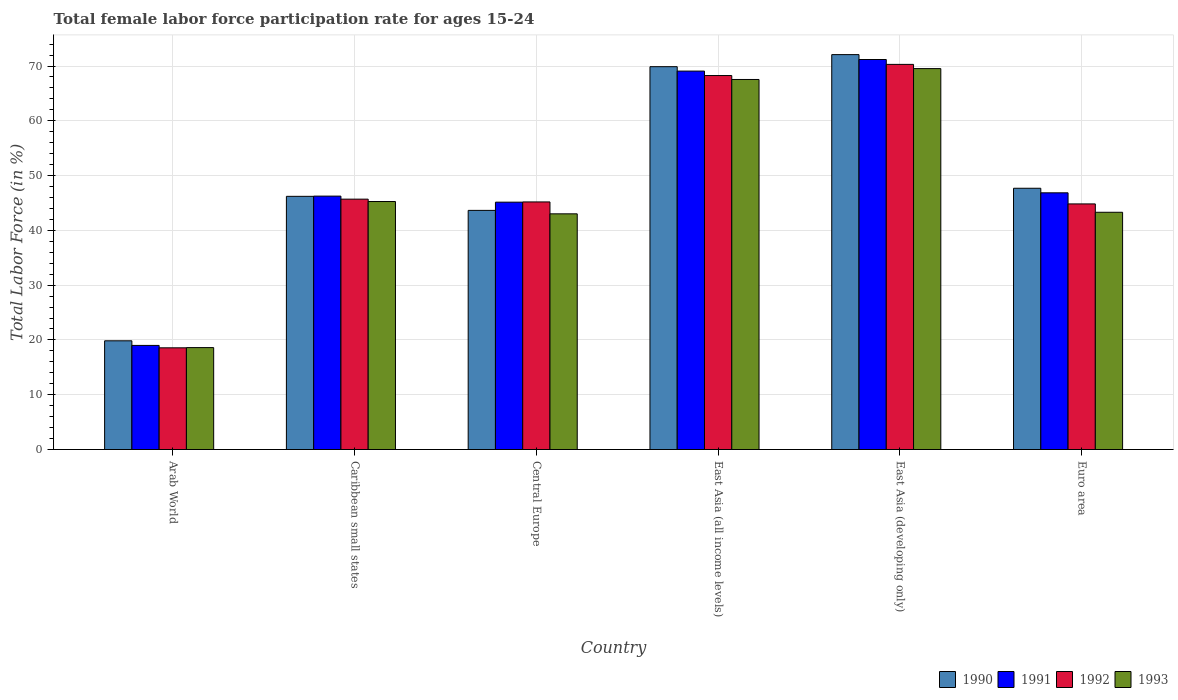Are the number of bars per tick equal to the number of legend labels?
Your answer should be compact. Yes. Are the number of bars on each tick of the X-axis equal?
Keep it short and to the point. Yes. How many bars are there on the 2nd tick from the left?
Keep it short and to the point. 4. What is the label of the 4th group of bars from the left?
Your answer should be very brief. East Asia (all income levels). What is the female labor force participation rate in 1992 in East Asia (developing only)?
Make the answer very short. 70.3. Across all countries, what is the maximum female labor force participation rate in 1990?
Give a very brief answer. 72.08. Across all countries, what is the minimum female labor force participation rate in 1990?
Make the answer very short. 19.84. In which country was the female labor force participation rate in 1990 maximum?
Your answer should be compact. East Asia (developing only). In which country was the female labor force participation rate in 1990 minimum?
Provide a succinct answer. Arab World. What is the total female labor force participation rate in 1993 in the graph?
Give a very brief answer. 287.27. What is the difference between the female labor force participation rate in 1990 in Central Europe and that in Euro area?
Your response must be concise. -4.04. What is the difference between the female labor force participation rate in 1993 in Euro area and the female labor force participation rate in 1991 in East Asia (developing only)?
Provide a short and direct response. -27.88. What is the average female labor force participation rate in 1991 per country?
Provide a succinct answer. 49.59. What is the difference between the female labor force participation rate of/in 1992 and female labor force participation rate of/in 1993 in East Asia (developing only)?
Provide a succinct answer. 0.77. In how many countries, is the female labor force participation rate in 1990 greater than 4 %?
Give a very brief answer. 6. What is the ratio of the female labor force participation rate in 1991 in Arab World to that in Central Europe?
Your response must be concise. 0.42. Is the difference between the female labor force participation rate in 1992 in Arab World and Caribbean small states greater than the difference between the female labor force participation rate in 1993 in Arab World and Caribbean small states?
Keep it short and to the point. No. What is the difference between the highest and the second highest female labor force participation rate in 1990?
Your answer should be very brief. 2.2. What is the difference between the highest and the lowest female labor force participation rate in 1990?
Provide a succinct answer. 52.24. Is the sum of the female labor force participation rate in 1990 in Arab World and Central Europe greater than the maximum female labor force participation rate in 1992 across all countries?
Your answer should be very brief. No. What does the 4th bar from the left in Euro area represents?
Keep it short and to the point. 1993. Is it the case that in every country, the sum of the female labor force participation rate in 1991 and female labor force participation rate in 1992 is greater than the female labor force participation rate in 1993?
Your response must be concise. Yes. How many bars are there?
Keep it short and to the point. 24. Are all the bars in the graph horizontal?
Make the answer very short. No. What is the difference between two consecutive major ticks on the Y-axis?
Offer a terse response. 10. Does the graph contain grids?
Give a very brief answer. Yes. What is the title of the graph?
Ensure brevity in your answer.  Total female labor force participation rate for ages 15-24. What is the label or title of the Y-axis?
Offer a terse response. Total Labor Force (in %). What is the Total Labor Force (in %) in 1990 in Arab World?
Your answer should be very brief. 19.84. What is the Total Labor Force (in %) in 1991 in Arab World?
Your response must be concise. 19. What is the Total Labor Force (in %) of 1992 in Arab World?
Make the answer very short. 18.56. What is the Total Labor Force (in %) in 1993 in Arab World?
Offer a terse response. 18.6. What is the Total Labor Force (in %) in 1990 in Caribbean small states?
Your answer should be compact. 46.21. What is the Total Labor Force (in %) in 1991 in Caribbean small states?
Offer a very short reply. 46.25. What is the Total Labor Force (in %) of 1992 in Caribbean small states?
Make the answer very short. 45.7. What is the Total Labor Force (in %) in 1993 in Caribbean small states?
Offer a terse response. 45.27. What is the Total Labor Force (in %) in 1990 in Central Europe?
Offer a very short reply. 43.65. What is the Total Labor Force (in %) in 1991 in Central Europe?
Provide a succinct answer. 45.15. What is the Total Labor Force (in %) in 1992 in Central Europe?
Offer a very short reply. 45.19. What is the Total Labor Force (in %) of 1993 in Central Europe?
Give a very brief answer. 43.02. What is the Total Labor Force (in %) in 1990 in East Asia (all income levels)?
Make the answer very short. 69.88. What is the Total Labor Force (in %) of 1991 in East Asia (all income levels)?
Give a very brief answer. 69.08. What is the Total Labor Force (in %) of 1992 in East Asia (all income levels)?
Provide a succinct answer. 68.26. What is the Total Labor Force (in %) of 1993 in East Asia (all income levels)?
Your answer should be very brief. 67.55. What is the Total Labor Force (in %) of 1990 in East Asia (developing only)?
Ensure brevity in your answer.  72.08. What is the Total Labor Force (in %) in 1991 in East Asia (developing only)?
Keep it short and to the point. 71.19. What is the Total Labor Force (in %) in 1992 in East Asia (developing only)?
Make the answer very short. 70.3. What is the Total Labor Force (in %) in 1993 in East Asia (developing only)?
Offer a terse response. 69.53. What is the Total Labor Force (in %) of 1990 in Euro area?
Keep it short and to the point. 47.69. What is the Total Labor Force (in %) in 1991 in Euro area?
Keep it short and to the point. 46.86. What is the Total Labor Force (in %) in 1992 in Euro area?
Provide a succinct answer. 44.83. What is the Total Labor Force (in %) in 1993 in Euro area?
Your response must be concise. 43.31. Across all countries, what is the maximum Total Labor Force (in %) in 1990?
Your response must be concise. 72.08. Across all countries, what is the maximum Total Labor Force (in %) in 1991?
Your answer should be very brief. 71.19. Across all countries, what is the maximum Total Labor Force (in %) of 1992?
Your answer should be compact. 70.3. Across all countries, what is the maximum Total Labor Force (in %) in 1993?
Ensure brevity in your answer.  69.53. Across all countries, what is the minimum Total Labor Force (in %) of 1990?
Ensure brevity in your answer.  19.84. Across all countries, what is the minimum Total Labor Force (in %) of 1991?
Make the answer very short. 19. Across all countries, what is the minimum Total Labor Force (in %) in 1992?
Keep it short and to the point. 18.56. Across all countries, what is the minimum Total Labor Force (in %) in 1993?
Ensure brevity in your answer.  18.6. What is the total Total Labor Force (in %) of 1990 in the graph?
Your response must be concise. 299.36. What is the total Total Labor Force (in %) of 1991 in the graph?
Keep it short and to the point. 297.53. What is the total Total Labor Force (in %) in 1992 in the graph?
Your response must be concise. 292.86. What is the total Total Labor Force (in %) of 1993 in the graph?
Your response must be concise. 287.27. What is the difference between the Total Labor Force (in %) of 1990 in Arab World and that in Caribbean small states?
Make the answer very short. -26.37. What is the difference between the Total Labor Force (in %) of 1991 in Arab World and that in Caribbean small states?
Keep it short and to the point. -27.25. What is the difference between the Total Labor Force (in %) of 1992 in Arab World and that in Caribbean small states?
Give a very brief answer. -27.14. What is the difference between the Total Labor Force (in %) of 1993 in Arab World and that in Caribbean small states?
Make the answer very short. -26.66. What is the difference between the Total Labor Force (in %) of 1990 in Arab World and that in Central Europe?
Keep it short and to the point. -23.81. What is the difference between the Total Labor Force (in %) in 1991 in Arab World and that in Central Europe?
Your answer should be very brief. -26.15. What is the difference between the Total Labor Force (in %) in 1992 in Arab World and that in Central Europe?
Provide a succinct answer. -26.63. What is the difference between the Total Labor Force (in %) in 1993 in Arab World and that in Central Europe?
Provide a short and direct response. -24.42. What is the difference between the Total Labor Force (in %) in 1990 in Arab World and that in East Asia (all income levels)?
Your answer should be very brief. -50.04. What is the difference between the Total Labor Force (in %) in 1991 in Arab World and that in East Asia (all income levels)?
Provide a short and direct response. -50.07. What is the difference between the Total Labor Force (in %) of 1992 in Arab World and that in East Asia (all income levels)?
Give a very brief answer. -49.7. What is the difference between the Total Labor Force (in %) in 1993 in Arab World and that in East Asia (all income levels)?
Your answer should be very brief. -48.94. What is the difference between the Total Labor Force (in %) in 1990 in Arab World and that in East Asia (developing only)?
Give a very brief answer. -52.24. What is the difference between the Total Labor Force (in %) of 1991 in Arab World and that in East Asia (developing only)?
Your answer should be compact. -52.19. What is the difference between the Total Labor Force (in %) in 1992 in Arab World and that in East Asia (developing only)?
Ensure brevity in your answer.  -51.74. What is the difference between the Total Labor Force (in %) of 1993 in Arab World and that in East Asia (developing only)?
Your answer should be compact. -50.93. What is the difference between the Total Labor Force (in %) in 1990 in Arab World and that in Euro area?
Your answer should be very brief. -27.85. What is the difference between the Total Labor Force (in %) in 1991 in Arab World and that in Euro area?
Offer a terse response. -27.85. What is the difference between the Total Labor Force (in %) in 1992 in Arab World and that in Euro area?
Your answer should be very brief. -26.27. What is the difference between the Total Labor Force (in %) of 1993 in Arab World and that in Euro area?
Provide a short and direct response. -24.7. What is the difference between the Total Labor Force (in %) of 1990 in Caribbean small states and that in Central Europe?
Ensure brevity in your answer.  2.56. What is the difference between the Total Labor Force (in %) in 1991 in Caribbean small states and that in Central Europe?
Your response must be concise. 1.1. What is the difference between the Total Labor Force (in %) in 1992 in Caribbean small states and that in Central Europe?
Provide a succinct answer. 0.51. What is the difference between the Total Labor Force (in %) in 1993 in Caribbean small states and that in Central Europe?
Ensure brevity in your answer.  2.25. What is the difference between the Total Labor Force (in %) in 1990 in Caribbean small states and that in East Asia (all income levels)?
Your answer should be compact. -23.67. What is the difference between the Total Labor Force (in %) in 1991 in Caribbean small states and that in East Asia (all income levels)?
Keep it short and to the point. -22.82. What is the difference between the Total Labor Force (in %) of 1992 in Caribbean small states and that in East Asia (all income levels)?
Keep it short and to the point. -22.56. What is the difference between the Total Labor Force (in %) of 1993 in Caribbean small states and that in East Asia (all income levels)?
Your answer should be very brief. -22.28. What is the difference between the Total Labor Force (in %) in 1990 in Caribbean small states and that in East Asia (developing only)?
Offer a very short reply. -25.87. What is the difference between the Total Labor Force (in %) of 1991 in Caribbean small states and that in East Asia (developing only)?
Make the answer very short. -24.94. What is the difference between the Total Labor Force (in %) of 1992 in Caribbean small states and that in East Asia (developing only)?
Keep it short and to the point. -24.6. What is the difference between the Total Labor Force (in %) of 1993 in Caribbean small states and that in East Asia (developing only)?
Offer a very short reply. -24.26. What is the difference between the Total Labor Force (in %) in 1990 in Caribbean small states and that in Euro area?
Provide a short and direct response. -1.48. What is the difference between the Total Labor Force (in %) of 1991 in Caribbean small states and that in Euro area?
Offer a terse response. -0.6. What is the difference between the Total Labor Force (in %) in 1992 in Caribbean small states and that in Euro area?
Your answer should be compact. 0.87. What is the difference between the Total Labor Force (in %) in 1993 in Caribbean small states and that in Euro area?
Your answer should be compact. 1.96. What is the difference between the Total Labor Force (in %) in 1990 in Central Europe and that in East Asia (all income levels)?
Provide a short and direct response. -26.23. What is the difference between the Total Labor Force (in %) of 1991 in Central Europe and that in East Asia (all income levels)?
Provide a succinct answer. -23.93. What is the difference between the Total Labor Force (in %) of 1992 in Central Europe and that in East Asia (all income levels)?
Provide a short and direct response. -23.07. What is the difference between the Total Labor Force (in %) of 1993 in Central Europe and that in East Asia (all income levels)?
Give a very brief answer. -24.53. What is the difference between the Total Labor Force (in %) of 1990 in Central Europe and that in East Asia (developing only)?
Your answer should be compact. -28.43. What is the difference between the Total Labor Force (in %) in 1991 in Central Europe and that in East Asia (developing only)?
Make the answer very short. -26.04. What is the difference between the Total Labor Force (in %) in 1992 in Central Europe and that in East Asia (developing only)?
Ensure brevity in your answer.  -25.11. What is the difference between the Total Labor Force (in %) of 1993 in Central Europe and that in East Asia (developing only)?
Offer a very short reply. -26.51. What is the difference between the Total Labor Force (in %) in 1990 in Central Europe and that in Euro area?
Offer a very short reply. -4.04. What is the difference between the Total Labor Force (in %) of 1991 in Central Europe and that in Euro area?
Keep it short and to the point. -1.7. What is the difference between the Total Labor Force (in %) in 1992 in Central Europe and that in Euro area?
Your response must be concise. 0.36. What is the difference between the Total Labor Force (in %) in 1993 in Central Europe and that in Euro area?
Your answer should be very brief. -0.29. What is the difference between the Total Labor Force (in %) in 1991 in East Asia (all income levels) and that in East Asia (developing only)?
Your answer should be compact. -2.11. What is the difference between the Total Labor Force (in %) in 1992 in East Asia (all income levels) and that in East Asia (developing only)?
Your answer should be very brief. -2.04. What is the difference between the Total Labor Force (in %) of 1993 in East Asia (all income levels) and that in East Asia (developing only)?
Make the answer very short. -1.98. What is the difference between the Total Labor Force (in %) of 1990 in East Asia (all income levels) and that in Euro area?
Ensure brevity in your answer.  22.19. What is the difference between the Total Labor Force (in %) of 1991 in East Asia (all income levels) and that in Euro area?
Your answer should be very brief. 22.22. What is the difference between the Total Labor Force (in %) of 1992 in East Asia (all income levels) and that in Euro area?
Give a very brief answer. 23.43. What is the difference between the Total Labor Force (in %) of 1993 in East Asia (all income levels) and that in Euro area?
Provide a succinct answer. 24.24. What is the difference between the Total Labor Force (in %) of 1990 in East Asia (developing only) and that in Euro area?
Your answer should be very brief. 24.39. What is the difference between the Total Labor Force (in %) of 1991 in East Asia (developing only) and that in Euro area?
Offer a very short reply. 24.34. What is the difference between the Total Labor Force (in %) of 1992 in East Asia (developing only) and that in Euro area?
Provide a short and direct response. 25.47. What is the difference between the Total Labor Force (in %) in 1993 in East Asia (developing only) and that in Euro area?
Give a very brief answer. 26.22. What is the difference between the Total Labor Force (in %) of 1990 in Arab World and the Total Labor Force (in %) of 1991 in Caribbean small states?
Make the answer very short. -26.41. What is the difference between the Total Labor Force (in %) of 1990 in Arab World and the Total Labor Force (in %) of 1992 in Caribbean small states?
Your answer should be compact. -25.86. What is the difference between the Total Labor Force (in %) of 1990 in Arab World and the Total Labor Force (in %) of 1993 in Caribbean small states?
Provide a succinct answer. -25.42. What is the difference between the Total Labor Force (in %) of 1991 in Arab World and the Total Labor Force (in %) of 1992 in Caribbean small states?
Ensure brevity in your answer.  -26.7. What is the difference between the Total Labor Force (in %) in 1991 in Arab World and the Total Labor Force (in %) in 1993 in Caribbean small states?
Your response must be concise. -26.27. What is the difference between the Total Labor Force (in %) of 1992 in Arab World and the Total Labor Force (in %) of 1993 in Caribbean small states?
Give a very brief answer. -26.7. What is the difference between the Total Labor Force (in %) in 1990 in Arab World and the Total Labor Force (in %) in 1991 in Central Europe?
Offer a terse response. -25.31. What is the difference between the Total Labor Force (in %) in 1990 in Arab World and the Total Labor Force (in %) in 1992 in Central Europe?
Ensure brevity in your answer.  -25.35. What is the difference between the Total Labor Force (in %) in 1990 in Arab World and the Total Labor Force (in %) in 1993 in Central Europe?
Make the answer very short. -23.17. What is the difference between the Total Labor Force (in %) of 1991 in Arab World and the Total Labor Force (in %) of 1992 in Central Europe?
Your answer should be compact. -26.19. What is the difference between the Total Labor Force (in %) of 1991 in Arab World and the Total Labor Force (in %) of 1993 in Central Europe?
Make the answer very short. -24.02. What is the difference between the Total Labor Force (in %) in 1992 in Arab World and the Total Labor Force (in %) in 1993 in Central Europe?
Ensure brevity in your answer.  -24.46. What is the difference between the Total Labor Force (in %) in 1990 in Arab World and the Total Labor Force (in %) in 1991 in East Asia (all income levels)?
Offer a terse response. -49.23. What is the difference between the Total Labor Force (in %) of 1990 in Arab World and the Total Labor Force (in %) of 1992 in East Asia (all income levels)?
Offer a terse response. -48.42. What is the difference between the Total Labor Force (in %) of 1990 in Arab World and the Total Labor Force (in %) of 1993 in East Asia (all income levels)?
Provide a succinct answer. -47.7. What is the difference between the Total Labor Force (in %) in 1991 in Arab World and the Total Labor Force (in %) in 1992 in East Asia (all income levels)?
Offer a very short reply. -49.26. What is the difference between the Total Labor Force (in %) of 1991 in Arab World and the Total Labor Force (in %) of 1993 in East Asia (all income levels)?
Make the answer very short. -48.54. What is the difference between the Total Labor Force (in %) of 1992 in Arab World and the Total Labor Force (in %) of 1993 in East Asia (all income levels)?
Your answer should be compact. -48.98. What is the difference between the Total Labor Force (in %) in 1990 in Arab World and the Total Labor Force (in %) in 1991 in East Asia (developing only)?
Offer a very short reply. -51.35. What is the difference between the Total Labor Force (in %) of 1990 in Arab World and the Total Labor Force (in %) of 1992 in East Asia (developing only)?
Keep it short and to the point. -50.46. What is the difference between the Total Labor Force (in %) of 1990 in Arab World and the Total Labor Force (in %) of 1993 in East Asia (developing only)?
Ensure brevity in your answer.  -49.68. What is the difference between the Total Labor Force (in %) of 1991 in Arab World and the Total Labor Force (in %) of 1992 in East Asia (developing only)?
Your response must be concise. -51.3. What is the difference between the Total Labor Force (in %) of 1991 in Arab World and the Total Labor Force (in %) of 1993 in East Asia (developing only)?
Offer a terse response. -50.53. What is the difference between the Total Labor Force (in %) in 1992 in Arab World and the Total Labor Force (in %) in 1993 in East Asia (developing only)?
Ensure brevity in your answer.  -50.97. What is the difference between the Total Labor Force (in %) of 1990 in Arab World and the Total Labor Force (in %) of 1991 in Euro area?
Offer a terse response. -27.01. What is the difference between the Total Labor Force (in %) of 1990 in Arab World and the Total Labor Force (in %) of 1992 in Euro area?
Give a very brief answer. -24.99. What is the difference between the Total Labor Force (in %) of 1990 in Arab World and the Total Labor Force (in %) of 1993 in Euro area?
Keep it short and to the point. -23.46. What is the difference between the Total Labor Force (in %) in 1991 in Arab World and the Total Labor Force (in %) in 1992 in Euro area?
Offer a very short reply. -25.83. What is the difference between the Total Labor Force (in %) of 1991 in Arab World and the Total Labor Force (in %) of 1993 in Euro area?
Offer a very short reply. -24.3. What is the difference between the Total Labor Force (in %) of 1992 in Arab World and the Total Labor Force (in %) of 1993 in Euro area?
Provide a succinct answer. -24.74. What is the difference between the Total Labor Force (in %) in 1990 in Caribbean small states and the Total Labor Force (in %) in 1991 in Central Europe?
Provide a succinct answer. 1.06. What is the difference between the Total Labor Force (in %) of 1990 in Caribbean small states and the Total Labor Force (in %) of 1992 in Central Europe?
Offer a very short reply. 1.02. What is the difference between the Total Labor Force (in %) in 1990 in Caribbean small states and the Total Labor Force (in %) in 1993 in Central Europe?
Provide a succinct answer. 3.19. What is the difference between the Total Labor Force (in %) in 1991 in Caribbean small states and the Total Labor Force (in %) in 1992 in Central Europe?
Provide a short and direct response. 1.06. What is the difference between the Total Labor Force (in %) of 1991 in Caribbean small states and the Total Labor Force (in %) of 1993 in Central Europe?
Keep it short and to the point. 3.23. What is the difference between the Total Labor Force (in %) in 1992 in Caribbean small states and the Total Labor Force (in %) in 1993 in Central Europe?
Your answer should be very brief. 2.68. What is the difference between the Total Labor Force (in %) of 1990 in Caribbean small states and the Total Labor Force (in %) of 1991 in East Asia (all income levels)?
Your answer should be compact. -22.86. What is the difference between the Total Labor Force (in %) in 1990 in Caribbean small states and the Total Labor Force (in %) in 1992 in East Asia (all income levels)?
Ensure brevity in your answer.  -22.05. What is the difference between the Total Labor Force (in %) in 1990 in Caribbean small states and the Total Labor Force (in %) in 1993 in East Asia (all income levels)?
Give a very brief answer. -21.33. What is the difference between the Total Labor Force (in %) of 1991 in Caribbean small states and the Total Labor Force (in %) of 1992 in East Asia (all income levels)?
Provide a succinct answer. -22.01. What is the difference between the Total Labor Force (in %) in 1991 in Caribbean small states and the Total Labor Force (in %) in 1993 in East Asia (all income levels)?
Your answer should be compact. -21.29. What is the difference between the Total Labor Force (in %) of 1992 in Caribbean small states and the Total Labor Force (in %) of 1993 in East Asia (all income levels)?
Your response must be concise. -21.84. What is the difference between the Total Labor Force (in %) of 1990 in Caribbean small states and the Total Labor Force (in %) of 1991 in East Asia (developing only)?
Keep it short and to the point. -24.98. What is the difference between the Total Labor Force (in %) in 1990 in Caribbean small states and the Total Labor Force (in %) in 1992 in East Asia (developing only)?
Offer a very short reply. -24.09. What is the difference between the Total Labor Force (in %) of 1990 in Caribbean small states and the Total Labor Force (in %) of 1993 in East Asia (developing only)?
Make the answer very short. -23.32. What is the difference between the Total Labor Force (in %) of 1991 in Caribbean small states and the Total Labor Force (in %) of 1992 in East Asia (developing only)?
Your response must be concise. -24.05. What is the difference between the Total Labor Force (in %) in 1991 in Caribbean small states and the Total Labor Force (in %) in 1993 in East Asia (developing only)?
Provide a succinct answer. -23.28. What is the difference between the Total Labor Force (in %) in 1992 in Caribbean small states and the Total Labor Force (in %) in 1993 in East Asia (developing only)?
Make the answer very short. -23.83. What is the difference between the Total Labor Force (in %) of 1990 in Caribbean small states and the Total Labor Force (in %) of 1991 in Euro area?
Provide a short and direct response. -0.64. What is the difference between the Total Labor Force (in %) in 1990 in Caribbean small states and the Total Labor Force (in %) in 1992 in Euro area?
Keep it short and to the point. 1.38. What is the difference between the Total Labor Force (in %) of 1990 in Caribbean small states and the Total Labor Force (in %) of 1993 in Euro area?
Give a very brief answer. 2.91. What is the difference between the Total Labor Force (in %) in 1991 in Caribbean small states and the Total Labor Force (in %) in 1992 in Euro area?
Provide a short and direct response. 1.42. What is the difference between the Total Labor Force (in %) in 1991 in Caribbean small states and the Total Labor Force (in %) in 1993 in Euro area?
Provide a short and direct response. 2.95. What is the difference between the Total Labor Force (in %) in 1992 in Caribbean small states and the Total Labor Force (in %) in 1993 in Euro area?
Provide a succinct answer. 2.4. What is the difference between the Total Labor Force (in %) of 1990 in Central Europe and the Total Labor Force (in %) of 1991 in East Asia (all income levels)?
Your answer should be compact. -25.43. What is the difference between the Total Labor Force (in %) of 1990 in Central Europe and the Total Labor Force (in %) of 1992 in East Asia (all income levels)?
Your response must be concise. -24.61. What is the difference between the Total Labor Force (in %) in 1990 in Central Europe and the Total Labor Force (in %) in 1993 in East Asia (all income levels)?
Keep it short and to the point. -23.89. What is the difference between the Total Labor Force (in %) in 1991 in Central Europe and the Total Labor Force (in %) in 1992 in East Asia (all income levels)?
Offer a very short reply. -23.11. What is the difference between the Total Labor Force (in %) of 1991 in Central Europe and the Total Labor Force (in %) of 1993 in East Asia (all income levels)?
Your answer should be compact. -22.39. What is the difference between the Total Labor Force (in %) of 1992 in Central Europe and the Total Labor Force (in %) of 1993 in East Asia (all income levels)?
Keep it short and to the point. -22.35. What is the difference between the Total Labor Force (in %) in 1990 in Central Europe and the Total Labor Force (in %) in 1991 in East Asia (developing only)?
Keep it short and to the point. -27.54. What is the difference between the Total Labor Force (in %) in 1990 in Central Europe and the Total Labor Force (in %) in 1992 in East Asia (developing only)?
Your response must be concise. -26.65. What is the difference between the Total Labor Force (in %) of 1990 in Central Europe and the Total Labor Force (in %) of 1993 in East Asia (developing only)?
Ensure brevity in your answer.  -25.88. What is the difference between the Total Labor Force (in %) of 1991 in Central Europe and the Total Labor Force (in %) of 1992 in East Asia (developing only)?
Provide a succinct answer. -25.15. What is the difference between the Total Labor Force (in %) of 1991 in Central Europe and the Total Labor Force (in %) of 1993 in East Asia (developing only)?
Offer a very short reply. -24.38. What is the difference between the Total Labor Force (in %) of 1992 in Central Europe and the Total Labor Force (in %) of 1993 in East Asia (developing only)?
Your answer should be compact. -24.34. What is the difference between the Total Labor Force (in %) in 1990 in Central Europe and the Total Labor Force (in %) in 1991 in Euro area?
Give a very brief answer. -3.21. What is the difference between the Total Labor Force (in %) in 1990 in Central Europe and the Total Labor Force (in %) in 1992 in Euro area?
Provide a succinct answer. -1.18. What is the difference between the Total Labor Force (in %) in 1990 in Central Europe and the Total Labor Force (in %) in 1993 in Euro area?
Ensure brevity in your answer.  0.34. What is the difference between the Total Labor Force (in %) of 1991 in Central Europe and the Total Labor Force (in %) of 1992 in Euro area?
Keep it short and to the point. 0.32. What is the difference between the Total Labor Force (in %) in 1991 in Central Europe and the Total Labor Force (in %) in 1993 in Euro area?
Provide a short and direct response. 1.84. What is the difference between the Total Labor Force (in %) of 1992 in Central Europe and the Total Labor Force (in %) of 1993 in Euro area?
Give a very brief answer. 1.89. What is the difference between the Total Labor Force (in %) of 1990 in East Asia (all income levels) and the Total Labor Force (in %) of 1991 in East Asia (developing only)?
Give a very brief answer. -1.31. What is the difference between the Total Labor Force (in %) of 1990 in East Asia (all income levels) and the Total Labor Force (in %) of 1992 in East Asia (developing only)?
Offer a terse response. -0.42. What is the difference between the Total Labor Force (in %) in 1990 in East Asia (all income levels) and the Total Labor Force (in %) in 1993 in East Asia (developing only)?
Make the answer very short. 0.35. What is the difference between the Total Labor Force (in %) of 1991 in East Asia (all income levels) and the Total Labor Force (in %) of 1992 in East Asia (developing only)?
Your answer should be very brief. -1.22. What is the difference between the Total Labor Force (in %) of 1991 in East Asia (all income levels) and the Total Labor Force (in %) of 1993 in East Asia (developing only)?
Make the answer very short. -0.45. What is the difference between the Total Labor Force (in %) in 1992 in East Asia (all income levels) and the Total Labor Force (in %) in 1993 in East Asia (developing only)?
Your response must be concise. -1.27. What is the difference between the Total Labor Force (in %) in 1990 in East Asia (all income levels) and the Total Labor Force (in %) in 1991 in Euro area?
Your answer should be very brief. 23.03. What is the difference between the Total Labor Force (in %) of 1990 in East Asia (all income levels) and the Total Labor Force (in %) of 1992 in Euro area?
Offer a terse response. 25.05. What is the difference between the Total Labor Force (in %) of 1990 in East Asia (all income levels) and the Total Labor Force (in %) of 1993 in Euro area?
Your response must be concise. 26.58. What is the difference between the Total Labor Force (in %) in 1991 in East Asia (all income levels) and the Total Labor Force (in %) in 1992 in Euro area?
Your answer should be very brief. 24.25. What is the difference between the Total Labor Force (in %) of 1991 in East Asia (all income levels) and the Total Labor Force (in %) of 1993 in Euro area?
Provide a succinct answer. 25.77. What is the difference between the Total Labor Force (in %) of 1992 in East Asia (all income levels) and the Total Labor Force (in %) of 1993 in Euro area?
Your answer should be very brief. 24.96. What is the difference between the Total Labor Force (in %) in 1990 in East Asia (developing only) and the Total Labor Force (in %) in 1991 in Euro area?
Offer a very short reply. 25.23. What is the difference between the Total Labor Force (in %) in 1990 in East Asia (developing only) and the Total Labor Force (in %) in 1992 in Euro area?
Make the answer very short. 27.25. What is the difference between the Total Labor Force (in %) of 1990 in East Asia (developing only) and the Total Labor Force (in %) of 1993 in Euro area?
Offer a terse response. 28.78. What is the difference between the Total Labor Force (in %) of 1991 in East Asia (developing only) and the Total Labor Force (in %) of 1992 in Euro area?
Keep it short and to the point. 26.36. What is the difference between the Total Labor Force (in %) of 1991 in East Asia (developing only) and the Total Labor Force (in %) of 1993 in Euro area?
Provide a short and direct response. 27.88. What is the difference between the Total Labor Force (in %) in 1992 in East Asia (developing only) and the Total Labor Force (in %) in 1993 in Euro area?
Your response must be concise. 27. What is the average Total Labor Force (in %) in 1990 per country?
Make the answer very short. 49.89. What is the average Total Labor Force (in %) in 1991 per country?
Provide a short and direct response. 49.59. What is the average Total Labor Force (in %) of 1992 per country?
Offer a terse response. 48.81. What is the average Total Labor Force (in %) of 1993 per country?
Offer a terse response. 47.88. What is the difference between the Total Labor Force (in %) of 1990 and Total Labor Force (in %) of 1991 in Arab World?
Make the answer very short. 0.84. What is the difference between the Total Labor Force (in %) in 1990 and Total Labor Force (in %) in 1992 in Arab World?
Offer a very short reply. 1.28. What is the difference between the Total Labor Force (in %) in 1990 and Total Labor Force (in %) in 1993 in Arab World?
Make the answer very short. 1.24. What is the difference between the Total Labor Force (in %) in 1991 and Total Labor Force (in %) in 1992 in Arab World?
Provide a succinct answer. 0.44. What is the difference between the Total Labor Force (in %) of 1991 and Total Labor Force (in %) of 1993 in Arab World?
Ensure brevity in your answer.  0.4. What is the difference between the Total Labor Force (in %) of 1992 and Total Labor Force (in %) of 1993 in Arab World?
Your answer should be very brief. -0.04. What is the difference between the Total Labor Force (in %) of 1990 and Total Labor Force (in %) of 1991 in Caribbean small states?
Offer a very short reply. -0.04. What is the difference between the Total Labor Force (in %) of 1990 and Total Labor Force (in %) of 1992 in Caribbean small states?
Give a very brief answer. 0.51. What is the difference between the Total Labor Force (in %) of 1990 and Total Labor Force (in %) of 1993 in Caribbean small states?
Ensure brevity in your answer.  0.95. What is the difference between the Total Labor Force (in %) in 1991 and Total Labor Force (in %) in 1992 in Caribbean small states?
Offer a terse response. 0.55. What is the difference between the Total Labor Force (in %) in 1991 and Total Labor Force (in %) in 1993 in Caribbean small states?
Your response must be concise. 0.99. What is the difference between the Total Labor Force (in %) in 1992 and Total Labor Force (in %) in 1993 in Caribbean small states?
Make the answer very short. 0.43. What is the difference between the Total Labor Force (in %) of 1990 and Total Labor Force (in %) of 1991 in Central Europe?
Keep it short and to the point. -1.5. What is the difference between the Total Labor Force (in %) of 1990 and Total Labor Force (in %) of 1992 in Central Europe?
Make the answer very short. -1.54. What is the difference between the Total Labor Force (in %) in 1990 and Total Labor Force (in %) in 1993 in Central Europe?
Ensure brevity in your answer.  0.63. What is the difference between the Total Labor Force (in %) in 1991 and Total Labor Force (in %) in 1992 in Central Europe?
Offer a terse response. -0.04. What is the difference between the Total Labor Force (in %) in 1991 and Total Labor Force (in %) in 1993 in Central Europe?
Make the answer very short. 2.13. What is the difference between the Total Labor Force (in %) of 1992 and Total Labor Force (in %) of 1993 in Central Europe?
Your answer should be compact. 2.17. What is the difference between the Total Labor Force (in %) in 1990 and Total Labor Force (in %) in 1991 in East Asia (all income levels)?
Your answer should be very brief. 0.81. What is the difference between the Total Labor Force (in %) in 1990 and Total Labor Force (in %) in 1992 in East Asia (all income levels)?
Keep it short and to the point. 1.62. What is the difference between the Total Labor Force (in %) in 1990 and Total Labor Force (in %) in 1993 in East Asia (all income levels)?
Your answer should be compact. 2.34. What is the difference between the Total Labor Force (in %) in 1991 and Total Labor Force (in %) in 1992 in East Asia (all income levels)?
Offer a very short reply. 0.81. What is the difference between the Total Labor Force (in %) of 1991 and Total Labor Force (in %) of 1993 in East Asia (all income levels)?
Offer a very short reply. 1.53. What is the difference between the Total Labor Force (in %) of 1992 and Total Labor Force (in %) of 1993 in East Asia (all income levels)?
Give a very brief answer. 0.72. What is the difference between the Total Labor Force (in %) of 1990 and Total Labor Force (in %) of 1991 in East Asia (developing only)?
Keep it short and to the point. 0.89. What is the difference between the Total Labor Force (in %) of 1990 and Total Labor Force (in %) of 1992 in East Asia (developing only)?
Your answer should be very brief. 1.78. What is the difference between the Total Labor Force (in %) of 1990 and Total Labor Force (in %) of 1993 in East Asia (developing only)?
Keep it short and to the point. 2.55. What is the difference between the Total Labor Force (in %) of 1991 and Total Labor Force (in %) of 1993 in East Asia (developing only)?
Provide a short and direct response. 1.66. What is the difference between the Total Labor Force (in %) in 1992 and Total Labor Force (in %) in 1993 in East Asia (developing only)?
Ensure brevity in your answer.  0.77. What is the difference between the Total Labor Force (in %) of 1990 and Total Labor Force (in %) of 1991 in Euro area?
Provide a short and direct response. 0.83. What is the difference between the Total Labor Force (in %) in 1990 and Total Labor Force (in %) in 1992 in Euro area?
Make the answer very short. 2.86. What is the difference between the Total Labor Force (in %) in 1990 and Total Labor Force (in %) in 1993 in Euro area?
Your answer should be very brief. 4.38. What is the difference between the Total Labor Force (in %) in 1991 and Total Labor Force (in %) in 1992 in Euro area?
Offer a very short reply. 2.02. What is the difference between the Total Labor Force (in %) in 1991 and Total Labor Force (in %) in 1993 in Euro area?
Ensure brevity in your answer.  3.55. What is the difference between the Total Labor Force (in %) of 1992 and Total Labor Force (in %) of 1993 in Euro area?
Your answer should be compact. 1.52. What is the ratio of the Total Labor Force (in %) of 1990 in Arab World to that in Caribbean small states?
Offer a terse response. 0.43. What is the ratio of the Total Labor Force (in %) in 1991 in Arab World to that in Caribbean small states?
Offer a terse response. 0.41. What is the ratio of the Total Labor Force (in %) in 1992 in Arab World to that in Caribbean small states?
Offer a terse response. 0.41. What is the ratio of the Total Labor Force (in %) in 1993 in Arab World to that in Caribbean small states?
Offer a terse response. 0.41. What is the ratio of the Total Labor Force (in %) of 1990 in Arab World to that in Central Europe?
Provide a short and direct response. 0.45. What is the ratio of the Total Labor Force (in %) of 1991 in Arab World to that in Central Europe?
Your answer should be compact. 0.42. What is the ratio of the Total Labor Force (in %) in 1992 in Arab World to that in Central Europe?
Offer a very short reply. 0.41. What is the ratio of the Total Labor Force (in %) in 1993 in Arab World to that in Central Europe?
Give a very brief answer. 0.43. What is the ratio of the Total Labor Force (in %) in 1990 in Arab World to that in East Asia (all income levels)?
Offer a terse response. 0.28. What is the ratio of the Total Labor Force (in %) of 1991 in Arab World to that in East Asia (all income levels)?
Provide a short and direct response. 0.28. What is the ratio of the Total Labor Force (in %) in 1992 in Arab World to that in East Asia (all income levels)?
Give a very brief answer. 0.27. What is the ratio of the Total Labor Force (in %) of 1993 in Arab World to that in East Asia (all income levels)?
Offer a very short reply. 0.28. What is the ratio of the Total Labor Force (in %) in 1990 in Arab World to that in East Asia (developing only)?
Give a very brief answer. 0.28. What is the ratio of the Total Labor Force (in %) of 1991 in Arab World to that in East Asia (developing only)?
Make the answer very short. 0.27. What is the ratio of the Total Labor Force (in %) of 1992 in Arab World to that in East Asia (developing only)?
Offer a very short reply. 0.26. What is the ratio of the Total Labor Force (in %) of 1993 in Arab World to that in East Asia (developing only)?
Ensure brevity in your answer.  0.27. What is the ratio of the Total Labor Force (in %) in 1990 in Arab World to that in Euro area?
Keep it short and to the point. 0.42. What is the ratio of the Total Labor Force (in %) in 1991 in Arab World to that in Euro area?
Provide a short and direct response. 0.41. What is the ratio of the Total Labor Force (in %) of 1992 in Arab World to that in Euro area?
Keep it short and to the point. 0.41. What is the ratio of the Total Labor Force (in %) of 1993 in Arab World to that in Euro area?
Provide a short and direct response. 0.43. What is the ratio of the Total Labor Force (in %) of 1990 in Caribbean small states to that in Central Europe?
Keep it short and to the point. 1.06. What is the ratio of the Total Labor Force (in %) of 1991 in Caribbean small states to that in Central Europe?
Offer a very short reply. 1.02. What is the ratio of the Total Labor Force (in %) in 1992 in Caribbean small states to that in Central Europe?
Offer a terse response. 1.01. What is the ratio of the Total Labor Force (in %) of 1993 in Caribbean small states to that in Central Europe?
Keep it short and to the point. 1.05. What is the ratio of the Total Labor Force (in %) of 1990 in Caribbean small states to that in East Asia (all income levels)?
Make the answer very short. 0.66. What is the ratio of the Total Labor Force (in %) in 1991 in Caribbean small states to that in East Asia (all income levels)?
Provide a short and direct response. 0.67. What is the ratio of the Total Labor Force (in %) of 1992 in Caribbean small states to that in East Asia (all income levels)?
Offer a very short reply. 0.67. What is the ratio of the Total Labor Force (in %) in 1993 in Caribbean small states to that in East Asia (all income levels)?
Keep it short and to the point. 0.67. What is the ratio of the Total Labor Force (in %) of 1990 in Caribbean small states to that in East Asia (developing only)?
Provide a succinct answer. 0.64. What is the ratio of the Total Labor Force (in %) of 1991 in Caribbean small states to that in East Asia (developing only)?
Offer a terse response. 0.65. What is the ratio of the Total Labor Force (in %) in 1992 in Caribbean small states to that in East Asia (developing only)?
Offer a very short reply. 0.65. What is the ratio of the Total Labor Force (in %) of 1993 in Caribbean small states to that in East Asia (developing only)?
Ensure brevity in your answer.  0.65. What is the ratio of the Total Labor Force (in %) of 1991 in Caribbean small states to that in Euro area?
Ensure brevity in your answer.  0.99. What is the ratio of the Total Labor Force (in %) in 1992 in Caribbean small states to that in Euro area?
Provide a succinct answer. 1.02. What is the ratio of the Total Labor Force (in %) in 1993 in Caribbean small states to that in Euro area?
Offer a terse response. 1.05. What is the ratio of the Total Labor Force (in %) of 1990 in Central Europe to that in East Asia (all income levels)?
Provide a short and direct response. 0.62. What is the ratio of the Total Labor Force (in %) of 1991 in Central Europe to that in East Asia (all income levels)?
Your answer should be very brief. 0.65. What is the ratio of the Total Labor Force (in %) in 1992 in Central Europe to that in East Asia (all income levels)?
Ensure brevity in your answer.  0.66. What is the ratio of the Total Labor Force (in %) in 1993 in Central Europe to that in East Asia (all income levels)?
Keep it short and to the point. 0.64. What is the ratio of the Total Labor Force (in %) of 1990 in Central Europe to that in East Asia (developing only)?
Provide a succinct answer. 0.61. What is the ratio of the Total Labor Force (in %) of 1991 in Central Europe to that in East Asia (developing only)?
Give a very brief answer. 0.63. What is the ratio of the Total Labor Force (in %) in 1992 in Central Europe to that in East Asia (developing only)?
Ensure brevity in your answer.  0.64. What is the ratio of the Total Labor Force (in %) in 1993 in Central Europe to that in East Asia (developing only)?
Your response must be concise. 0.62. What is the ratio of the Total Labor Force (in %) in 1990 in Central Europe to that in Euro area?
Provide a succinct answer. 0.92. What is the ratio of the Total Labor Force (in %) in 1991 in Central Europe to that in Euro area?
Offer a very short reply. 0.96. What is the ratio of the Total Labor Force (in %) of 1990 in East Asia (all income levels) to that in East Asia (developing only)?
Your response must be concise. 0.97. What is the ratio of the Total Labor Force (in %) of 1991 in East Asia (all income levels) to that in East Asia (developing only)?
Keep it short and to the point. 0.97. What is the ratio of the Total Labor Force (in %) in 1993 in East Asia (all income levels) to that in East Asia (developing only)?
Ensure brevity in your answer.  0.97. What is the ratio of the Total Labor Force (in %) in 1990 in East Asia (all income levels) to that in Euro area?
Keep it short and to the point. 1.47. What is the ratio of the Total Labor Force (in %) of 1991 in East Asia (all income levels) to that in Euro area?
Make the answer very short. 1.47. What is the ratio of the Total Labor Force (in %) in 1992 in East Asia (all income levels) to that in Euro area?
Make the answer very short. 1.52. What is the ratio of the Total Labor Force (in %) in 1993 in East Asia (all income levels) to that in Euro area?
Give a very brief answer. 1.56. What is the ratio of the Total Labor Force (in %) of 1990 in East Asia (developing only) to that in Euro area?
Offer a very short reply. 1.51. What is the ratio of the Total Labor Force (in %) in 1991 in East Asia (developing only) to that in Euro area?
Offer a very short reply. 1.52. What is the ratio of the Total Labor Force (in %) of 1992 in East Asia (developing only) to that in Euro area?
Provide a succinct answer. 1.57. What is the ratio of the Total Labor Force (in %) in 1993 in East Asia (developing only) to that in Euro area?
Give a very brief answer. 1.61. What is the difference between the highest and the second highest Total Labor Force (in %) in 1991?
Your answer should be compact. 2.11. What is the difference between the highest and the second highest Total Labor Force (in %) of 1992?
Your answer should be very brief. 2.04. What is the difference between the highest and the second highest Total Labor Force (in %) of 1993?
Ensure brevity in your answer.  1.98. What is the difference between the highest and the lowest Total Labor Force (in %) in 1990?
Your answer should be compact. 52.24. What is the difference between the highest and the lowest Total Labor Force (in %) of 1991?
Offer a terse response. 52.19. What is the difference between the highest and the lowest Total Labor Force (in %) in 1992?
Make the answer very short. 51.74. What is the difference between the highest and the lowest Total Labor Force (in %) of 1993?
Your answer should be compact. 50.93. 